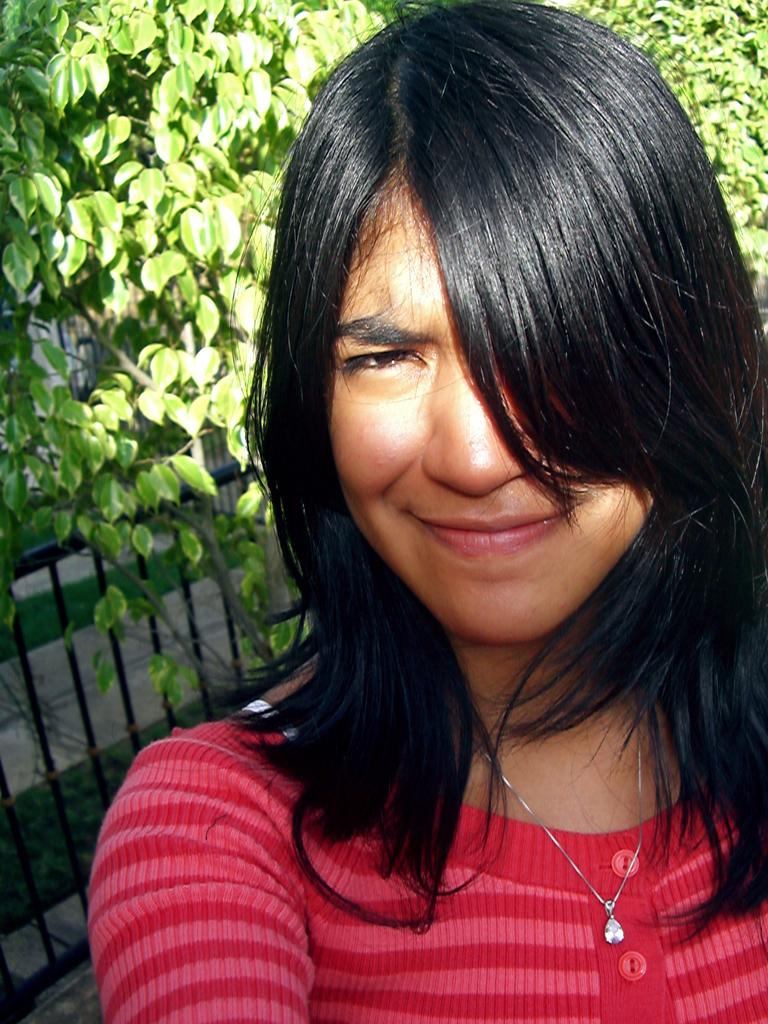Who is present in the image? There is a woman in the image. What is the woman doing in the image? The woman is smiling in the image. What is the woman wearing in the image? The woman is wearing a red sweater in the image. What can be seen on the left side of the image? There is an iron frame on the left side of the image. What is visible at the top of the image? There is a tree visible at the top of the image. What type of owl can be seen perched on the iron frame in the image? There is no owl present in the image; it features a woman wearing a red sweater and a tree visible at the top of the image. What kind of butter is being used to decorate the sweater in the image? There is no butter present in the image; the woman is wearing a red sweater without any decorations. 